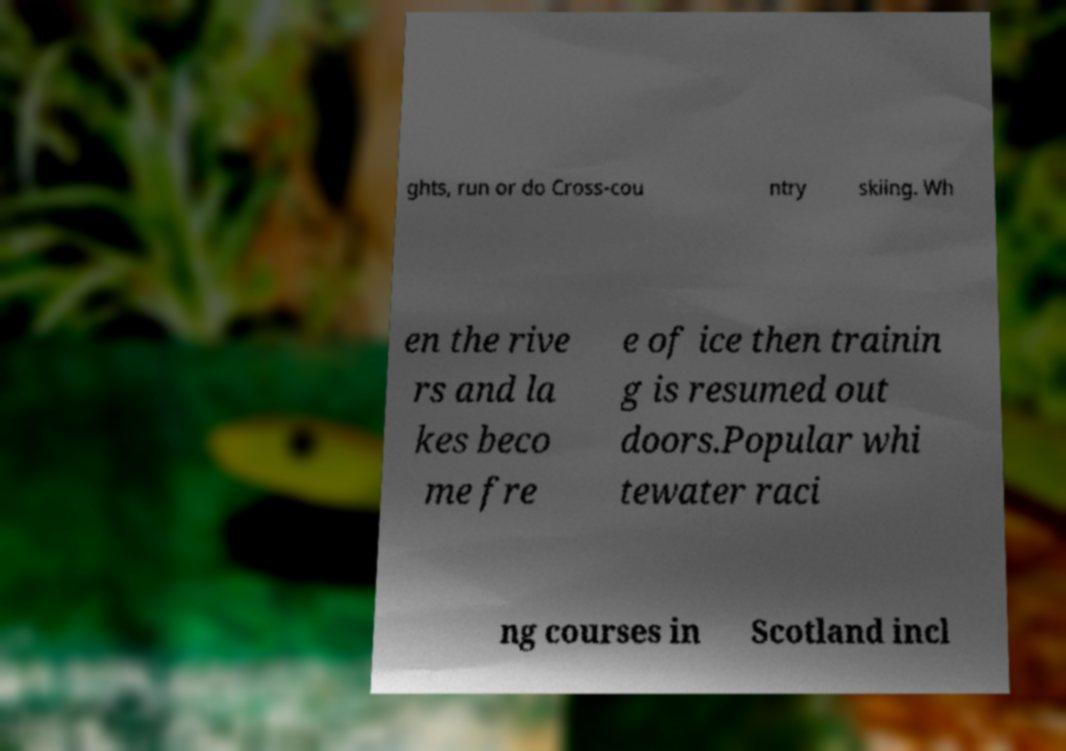There's text embedded in this image that I need extracted. Can you transcribe it verbatim? ghts, run or do Cross-cou ntry skiing. Wh en the rive rs and la kes beco me fre e of ice then trainin g is resumed out doors.Popular whi tewater raci ng courses in Scotland incl 